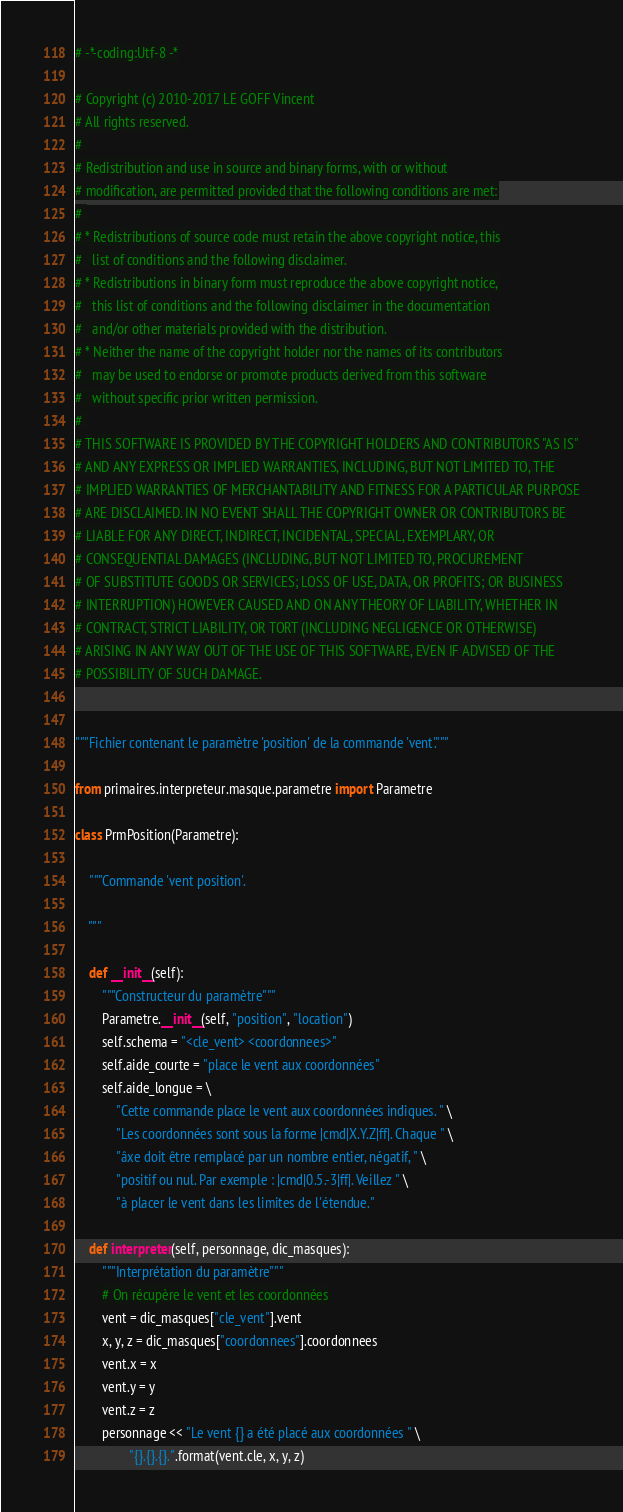Convert code to text. <code><loc_0><loc_0><loc_500><loc_500><_Python_># -*-coding:Utf-8 -*

# Copyright (c) 2010-2017 LE GOFF Vincent
# All rights reserved.
# 
# Redistribution and use in source and binary forms, with or without
# modification, are permitted provided that the following conditions are met:
# 
# * Redistributions of source code must retain the above copyright notice, this
#   list of conditions and the following disclaimer.
# * Redistributions in binary form must reproduce the above copyright notice,
#   this list of conditions and the following disclaimer in the documentation
#   and/or other materials provided with the distribution.
# * Neither the name of the copyright holder nor the names of its contributors
#   may be used to endorse or promote products derived from this software
#   without specific prior written permission.
# 
# THIS SOFTWARE IS PROVIDED BY THE COPYRIGHT HOLDERS AND CONTRIBUTORS "AS IS"
# AND ANY EXPRESS OR IMPLIED WARRANTIES, INCLUDING, BUT NOT LIMITED TO, THE
# IMPLIED WARRANTIES OF MERCHANTABILITY AND FITNESS FOR A PARTICULAR PURPOSE
# ARE DISCLAIMED. IN NO EVENT SHALL THE COPYRIGHT OWNER OR CONTRIBUTORS BE
# LIABLE FOR ANY DIRECT, INDIRECT, INCIDENTAL, SPECIAL, EXEMPLARY, OR
# CONSEQUENTIAL DAMAGES (INCLUDING, BUT NOT LIMITED TO, PROCUREMENT
# OF SUBSTITUTE GOODS OR SERVICES; LOSS OF USE, DATA, OR PROFITS; OR BUSINESS
# INTERRUPTION) HOWEVER CAUSED AND ON ANY THEORY OF LIABILITY, WHETHER IN
# CONTRACT, STRICT LIABILITY, OR TORT (INCLUDING NEGLIGENCE OR OTHERWISE)
# ARISING IN ANY WAY OUT OF THE USE OF THIS SOFTWARE, EVEN IF ADVISED OF THE
# POSSIBILITY OF SUCH DAMAGE.


"""Fichier contenant le paramètre 'position' de la commande 'vent'."""

from primaires.interpreteur.masque.parametre import Parametre

class PrmPosition(Parametre):
    
    """Commande 'vent position'.
    
    """
    
    def __init__(self):
        """Constructeur du paramètre"""
        Parametre.__init__(self, "position", "location")
        self.schema = "<cle_vent> <coordonnees>"
        self.aide_courte = "place le vent aux coordonnées"
        self.aide_longue = \
            "Cette commande place le vent aux coordonnées indiques. " \
            "Les coordonnées sont sous la forme |cmd|X.Y.Z|ff|. Chaque " \
            "âxe doit être remplacé par un nombre entier, négatif, " \
            "positif ou nul. Par exemple : |cmd|0.5.-3|ff|. Veillez " \
            "à placer le vent dans les limites de l'étendue."
    
    def interpreter(self, personnage, dic_masques):
        """Interprétation du paramètre"""
        # On récupère le vent et les coordonnées
        vent = dic_masques["cle_vent"].vent
        x, y, z = dic_masques["coordonnees"].coordonnees
        vent.x = x
        vent.y = y
        vent.z = z
        personnage << "Le vent {} a été placé aux coordonnées " \
                "{}.{}.{}.".format(vent.cle, x, y, z)
</code> 